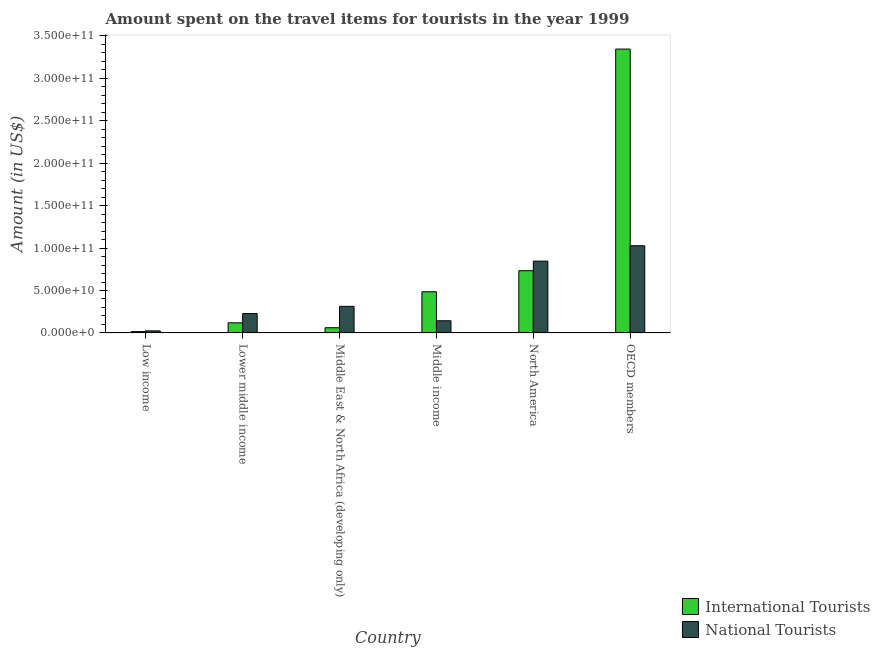How many different coloured bars are there?
Your answer should be very brief. 2. Are the number of bars on each tick of the X-axis equal?
Keep it short and to the point. Yes. What is the label of the 2nd group of bars from the left?
Provide a short and direct response. Lower middle income. In how many cases, is the number of bars for a given country not equal to the number of legend labels?
Your answer should be compact. 0. What is the amount spent on travel items of national tourists in Low income?
Your response must be concise. 2.42e+09. Across all countries, what is the maximum amount spent on travel items of national tourists?
Give a very brief answer. 1.03e+11. Across all countries, what is the minimum amount spent on travel items of national tourists?
Keep it short and to the point. 2.42e+09. In which country was the amount spent on travel items of national tourists maximum?
Give a very brief answer. OECD members. In which country was the amount spent on travel items of national tourists minimum?
Offer a very short reply. Low income. What is the total amount spent on travel items of international tourists in the graph?
Keep it short and to the point. 4.76e+11. What is the difference between the amount spent on travel items of international tourists in Middle income and that in North America?
Give a very brief answer. -2.48e+1. What is the difference between the amount spent on travel items of international tourists in Low income and the amount spent on travel items of national tourists in Middle East & North Africa (developing only)?
Your answer should be very brief. -2.98e+1. What is the average amount spent on travel items of national tourists per country?
Your response must be concise. 4.30e+1. What is the difference between the amount spent on travel items of national tourists and amount spent on travel items of international tourists in Lower middle income?
Keep it short and to the point. 1.09e+1. What is the ratio of the amount spent on travel items of international tourists in Low income to that in Lower middle income?
Provide a short and direct response. 0.13. Is the amount spent on travel items of international tourists in Lower middle income less than that in Middle East & North Africa (developing only)?
Make the answer very short. No. What is the difference between the highest and the second highest amount spent on travel items of national tourists?
Give a very brief answer. 1.81e+1. What is the difference between the highest and the lowest amount spent on travel items of international tourists?
Give a very brief answer. 3.33e+11. In how many countries, is the amount spent on travel items of national tourists greater than the average amount spent on travel items of national tourists taken over all countries?
Provide a succinct answer. 2. What does the 1st bar from the left in OECD members represents?
Your answer should be very brief. International Tourists. What does the 2nd bar from the right in Lower middle income represents?
Provide a short and direct response. International Tourists. How many countries are there in the graph?
Keep it short and to the point. 6. Are the values on the major ticks of Y-axis written in scientific E-notation?
Offer a terse response. Yes. Does the graph contain any zero values?
Keep it short and to the point. No. Where does the legend appear in the graph?
Provide a succinct answer. Bottom right. What is the title of the graph?
Make the answer very short. Amount spent on the travel items for tourists in the year 1999. Does "Working only" appear as one of the legend labels in the graph?
Keep it short and to the point. No. What is the label or title of the X-axis?
Your response must be concise. Country. What is the label or title of the Y-axis?
Offer a very short reply. Amount (in US$). What is the Amount (in US$) in International Tourists in Low income?
Provide a succinct answer. 1.56e+09. What is the Amount (in US$) of National Tourists in Low income?
Your response must be concise. 2.42e+09. What is the Amount (in US$) in International Tourists in Lower middle income?
Provide a short and direct response. 1.19e+1. What is the Amount (in US$) of National Tourists in Lower middle income?
Give a very brief answer. 2.28e+1. What is the Amount (in US$) in International Tourists in Middle East & North Africa (developing only)?
Make the answer very short. 6.13e+09. What is the Amount (in US$) in National Tourists in Middle East & North Africa (developing only)?
Your response must be concise. 3.13e+1. What is the Amount (in US$) of International Tourists in Middle income?
Keep it short and to the point. 4.85e+1. What is the Amount (in US$) in National Tourists in Middle income?
Offer a very short reply. 1.43e+1. What is the Amount (in US$) of International Tourists in North America?
Your response must be concise. 7.33e+1. What is the Amount (in US$) in National Tourists in North America?
Offer a terse response. 8.46e+1. What is the Amount (in US$) of International Tourists in OECD members?
Your answer should be compact. 3.34e+11. What is the Amount (in US$) in National Tourists in OECD members?
Ensure brevity in your answer.  1.03e+11. Across all countries, what is the maximum Amount (in US$) of International Tourists?
Your response must be concise. 3.34e+11. Across all countries, what is the maximum Amount (in US$) of National Tourists?
Keep it short and to the point. 1.03e+11. Across all countries, what is the minimum Amount (in US$) in International Tourists?
Give a very brief answer. 1.56e+09. Across all countries, what is the minimum Amount (in US$) of National Tourists?
Provide a short and direct response. 2.42e+09. What is the total Amount (in US$) of International Tourists in the graph?
Make the answer very short. 4.76e+11. What is the total Amount (in US$) in National Tourists in the graph?
Your answer should be very brief. 2.58e+11. What is the difference between the Amount (in US$) of International Tourists in Low income and that in Lower middle income?
Give a very brief answer. -1.04e+1. What is the difference between the Amount (in US$) of National Tourists in Low income and that in Lower middle income?
Give a very brief answer. -2.04e+1. What is the difference between the Amount (in US$) of International Tourists in Low income and that in Middle East & North Africa (developing only)?
Give a very brief answer. -4.57e+09. What is the difference between the Amount (in US$) of National Tourists in Low income and that in Middle East & North Africa (developing only)?
Your answer should be compact. -2.89e+1. What is the difference between the Amount (in US$) in International Tourists in Low income and that in Middle income?
Keep it short and to the point. -4.69e+1. What is the difference between the Amount (in US$) in National Tourists in Low income and that in Middle income?
Provide a short and direct response. -1.19e+1. What is the difference between the Amount (in US$) of International Tourists in Low income and that in North America?
Keep it short and to the point. -7.17e+1. What is the difference between the Amount (in US$) of National Tourists in Low income and that in North America?
Ensure brevity in your answer.  -8.22e+1. What is the difference between the Amount (in US$) of International Tourists in Low income and that in OECD members?
Provide a succinct answer. -3.33e+11. What is the difference between the Amount (in US$) of National Tourists in Low income and that in OECD members?
Keep it short and to the point. -1.00e+11. What is the difference between the Amount (in US$) of International Tourists in Lower middle income and that in Middle East & North Africa (developing only)?
Give a very brief answer. 5.80e+09. What is the difference between the Amount (in US$) in National Tourists in Lower middle income and that in Middle East & North Africa (developing only)?
Provide a short and direct response. -8.50e+09. What is the difference between the Amount (in US$) in International Tourists in Lower middle income and that in Middle income?
Keep it short and to the point. -3.66e+1. What is the difference between the Amount (in US$) in National Tourists in Lower middle income and that in Middle income?
Provide a short and direct response. 8.48e+09. What is the difference between the Amount (in US$) of International Tourists in Lower middle income and that in North America?
Ensure brevity in your answer.  -6.14e+1. What is the difference between the Amount (in US$) of National Tourists in Lower middle income and that in North America?
Your response must be concise. -6.18e+1. What is the difference between the Amount (in US$) of International Tourists in Lower middle income and that in OECD members?
Your answer should be compact. -3.22e+11. What is the difference between the Amount (in US$) in National Tourists in Lower middle income and that in OECD members?
Your answer should be very brief. -7.99e+1. What is the difference between the Amount (in US$) in International Tourists in Middle East & North Africa (developing only) and that in Middle income?
Provide a short and direct response. -4.24e+1. What is the difference between the Amount (in US$) in National Tourists in Middle East & North Africa (developing only) and that in Middle income?
Provide a short and direct response. 1.70e+1. What is the difference between the Amount (in US$) in International Tourists in Middle East & North Africa (developing only) and that in North America?
Provide a short and direct response. -6.72e+1. What is the difference between the Amount (in US$) in National Tourists in Middle East & North Africa (developing only) and that in North America?
Your answer should be compact. -5.33e+1. What is the difference between the Amount (in US$) of International Tourists in Middle East & North Africa (developing only) and that in OECD members?
Provide a short and direct response. -3.28e+11. What is the difference between the Amount (in US$) of National Tourists in Middle East & North Africa (developing only) and that in OECD members?
Provide a short and direct response. -7.14e+1. What is the difference between the Amount (in US$) of International Tourists in Middle income and that in North America?
Your answer should be very brief. -2.48e+1. What is the difference between the Amount (in US$) in National Tourists in Middle income and that in North America?
Give a very brief answer. -7.03e+1. What is the difference between the Amount (in US$) in International Tourists in Middle income and that in OECD members?
Provide a short and direct response. -2.86e+11. What is the difference between the Amount (in US$) in National Tourists in Middle income and that in OECD members?
Offer a terse response. -8.84e+1. What is the difference between the Amount (in US$) of International Tourists in North America and that in OECD members?
Offer a terse response. -2.61e+11. What is the difference between the Amount (in US$) in National Tourists in North America and that in OECD members?
Give a very brief answer. -1.81e+1. What is the difference between the Amount (in US$) in International Tourists in Low income and the Amount (in US$) in National Tourists in Lower middle income?
Your response must be concise. -2.13e+1. What is the difference between the Amount (in US$) of International Tourists in Low income and the Amount (in US$) of National Tourists in Middle East & North Africa (developing only)?
Ensure brevity in your answer.  -2.98e+1. What is the difference between the Amount (in US$) in International Tourists in Low income and the Amount (in US$) in National Tourists in Middle income?
Offer a terse response. -1.28e+1. What is the difference between the Amount (in US$) of International Tourists in Low income and the Amount (in US$) of National Tourists in North America?
Provide a succinct answer. -8.30e+1. What is the difference between the Amount (in US$) of International Tourists in Low income and the Amount (in US$) of National Tourists in OECD members?
Offer a very short reply. -1.01e+11. What is the difference between the Amount (in US$) of International Tourists in Lower middle income and the Amount (in US$) of National Tourists in Middle East & North Africa (developing only)?
Provide a short and direct response. -1.94e+1. What is the difference between the Amount (in US$) of International Tourists in Lower middle income and the Amount (in US$) of National Tourists in Middle income?
Offer a terse response. -2.41e+09. What is the difference between the Amount (in US$) in International Tourists in Lower middle income and the Amount (in US$) in National Tourists in North America?
Your answer should be compact. -7.27e+1. What is the difference between the Amount (in US$) in International Tourists in Lower middle income and the Amount (in US$) in National Tourists in OECD members?
Give a very brief answer. -9.08e+1. What is the difference between the Amount (in US$) in International Tourists in Middle East & North Africa (developing only) and the Amount (in US$) in National Tourists in Middle income?
Your answer should be very brief. -8.21e+09. What is the difference between the Amount (in US$) in International Tourists in Middle East & North Africa (developing only) and the Amount (in US$) in National Tourists in North America?
Your answer should be compact. -7.85e+1. What is the difference between the Amount (in US$) of International Tourists in Middle East & North Africa (developing only) and the Amount (in US$) of National Tourists in OECD members?
Your answer should be compact. -9.66e+1. What is the difference between the Amount (in US$) in International Tourists in Middle income and the Amount (in US$) in National Tourists in North America?
Your response must be concise. -3.61e+1. What is the difference between the Amount (in US$) in International Tourists in Middle income and the Amount (in US$) in National Tourists in OECD members?
Keep it short and to the point. -5.42e+1. What is the difference between the Amount (in US$) of International Tourists in North America and the Amount (in US$) of National Tourists in OECD members?
Make the answer very short. -2.94e+1. What is the average Amount (in US$) of International Tourists per country?
Ensure brevity in your answer.  7.93e+1. What is the average Amount (in US$) in National Tourists per country?
Your answer should be compact. 4.30e+1. What is the difference between the Amount (in US$) of International Tourists and Amount (in US$) of National Tourists in Low income?
Make the answer very short. -8.65e+08. What is the difference between the Amount (in US$) of International Tourists and Amount (in US$) of National Tourists in Lower middle income?
Provide a short and direct response. -1.09e+1. What is the difference between the Amount (in US$) in International Tourists and Amount (in US$) in National Tourists in Middle East & North Africa (developing only)?
Your answer should be compact. -2.52e+1. What is the difference between the Amount (in US$) in International Tourists and Amount (in US$) in National Tourists in Middle income?
Offer a terse response. 3.42e+1. What is the difference between the Amount (in US$) in International Tourists and Amount (in US$) in National Tourists in North America?
Your answer should be compact. -1.13e+1. What is the difference between the Amount (in US$) of International Tourists and Amount (in US$) of National Tourists in OECD members?
Your answer should be very brief. 2.32e+11. What is the ratio of the Amount (in US$) in International Tourists in Low income to that in Lower middle income?
Offer a very short reply. 0.13. What is the ratio of the Amount (in US$) in National Tourists in Low income to that in Lower middle income?
Provide a short and direct response. 0.11. What is the ratio of the Amount (in US$) of International Tourists in Low income to that in Middle East & North Africa (developing only)?
Keep it short and to the point. 0.25. What is the ratio of the Amount (in US$) in National Tourists in Low income to that in Middle East & North Africa (developing only)?
Give a very brief answer. 0.08. What is the ratio of the Amount (in US$) of International Tourists in Low income to that in Middle income?
Provide a short and direct response. 0.03. What is the ratio of the Amount (in US$) in National Tourists in Low income to that in Middle income?
Make the answer very short. 0.17. What is the ratio of the Amount (in US$) of International Tourists in Low income to that in North America?
Offer a terse response. 0.02. What is the ratio of the Amount (in US$) of National Tourists in Low income to that in North America?
Provide a succinct answer. 0.03. What is the ratio of the Amount (in US$) of International Tourists in Low income to that in OECD members?
Provide a short and direct response. 0. What is the ratio of the Amount (in US$) of National Tourists in Low income to that in OECD members?
Give a very brief answer. 0.02. What is the ratio of the Amount (in US$) in International Tourists in Lower middle income to that in Middle East & North Africa (developing only)?
Give a very brief answer. 1.95. What is the ratio of the Amount (in US$) of National Tourists in Lower middle income to that in Middle East & North Africa (developing only)?
Your answer should be very brief. 0.73. What is the ratio of the Amount (in US$) of International Tourists in Lower middle income to that in Middle income?
Make the answer very short. 0.25. What is the ratio of the Amount (in US$) of National Tourists in Lower middle income to that in Middle income?
Offer a very short reply. 1.59. What is the ratio of the Amount (in US$) in International Tourists in Lower middle income to that in North America?
Your answer should be compact. 0.16. What is the ratio of the Amount (in US$) in National Tourists in Lower middle income to that in North America?
Make the answer very short. 0.27. What is the ratio of the Amount (in US$) of International Tourists in Lower middle income to that in OECD members?
Ensure brevity in your answer.  0.04. What is the ratio of the Amount (in US$) of National Tourists in Lower middle income to that in OECD members?
Provide a succinct answer. 0.22. What is the ratio of the Amount (in US$) in International Tourists in Middle East & North Africa (developing only) to that in Middle income?
Offer a terse response. 0.13. What is the ratio of the Amount (in US$) of National Tourists in Middle East & North Africa (developing only) to that in Middle income?
Make the answer very short. 2.18. What is the ratio of the Amount (in US$) of International Tourists in Middle East & North Africa (developing only) to that in North America?
Offer a terse response. 0.08. What is the ratio of the Amount (in US$) in National Tourists in Middle East & North Africa (developing only) to that in North America?
Offer a terse response. 0.37. What is the ratio of the Amount (in US$) of International Tourists in Middle East & North Africa (developing only) to that in OECD members?
Provide a succinct answer. 0.02. What is the ratio of the Amount (in US$) of National Tourists in Middle East & North Africa (developing only) to that in OECD members?
Make the answer very short. 0.3. What is the ratio of the Amount (in US$) in International Tourists in Middle income to that in North America?
Offer a terse response. 0.66. What is the ratio of the Amount (in US$) of National Tourists in Middle income to that in North America?
Keep it short and to the point. 0.17. What is the ratio of the Amount (in US$) of International Tourists in Middle income to that in OECD members?
Offer a terse response. 0.15. What is the ratio of the Amount (in US$) of National Tourists in Middle income to that in OECD members?
Offer a very short reply. 0.14. What is the ratio of the Amount (in US$) in International Tourists in North America to that in OECD members?
Your response must be concise. 0.22. What is the ratio of the Amount (in US$) of National Tourists in North America to that in OECD members?
Ensure brevity in your answer.  0.82. What is the difference between the highest and the second highest Amount (in US$) of International Tourists?
Provide a succinct answer. 2.61e+11. What is the difference between the highest and the second highest Amount (in US$) of National Tourists?
Your response must be concise. 1.81e+1. What is the difference between the highest and the lowest Amount (in US$) in International Tourists?
Ensure brevity in your answer.  3.33e+11. What is the difference between the highest and the lowest Amount (in US$) in National Tourists?
Provide a succinct answer. 1.00e+11. 